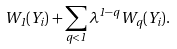Convert formula to latex. <formula><loc_0><loc_0><loc_500><loc_500>W _ { 1 } ( Y _ { i } ) + \sum _ { q < 1 } \lambda ^ { 1 - q } \, W _ { q } ( Y _ { i } ) .</formula> 